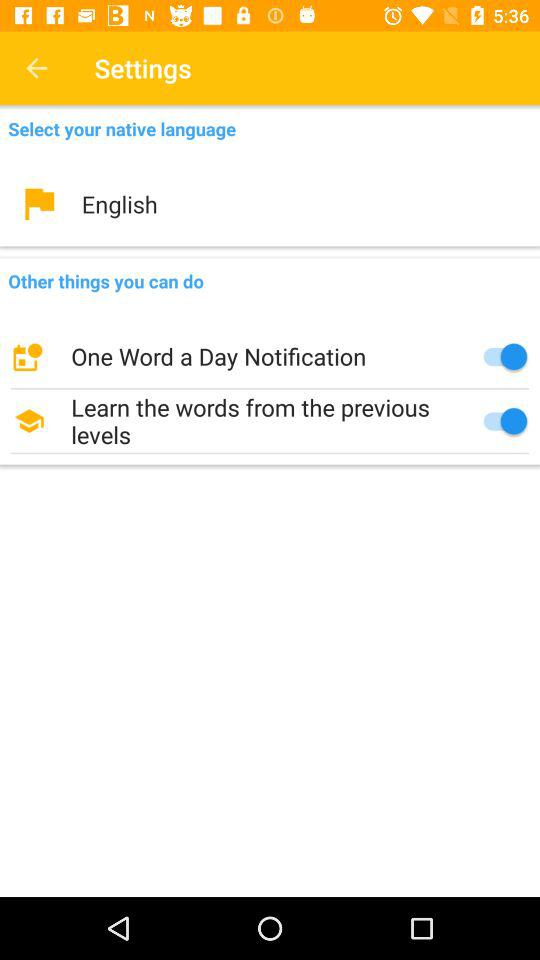Name the options that are enabled in "Other things you can do"? The options are "One Word a Day Notification" and "Learn the words from the previous levels". 